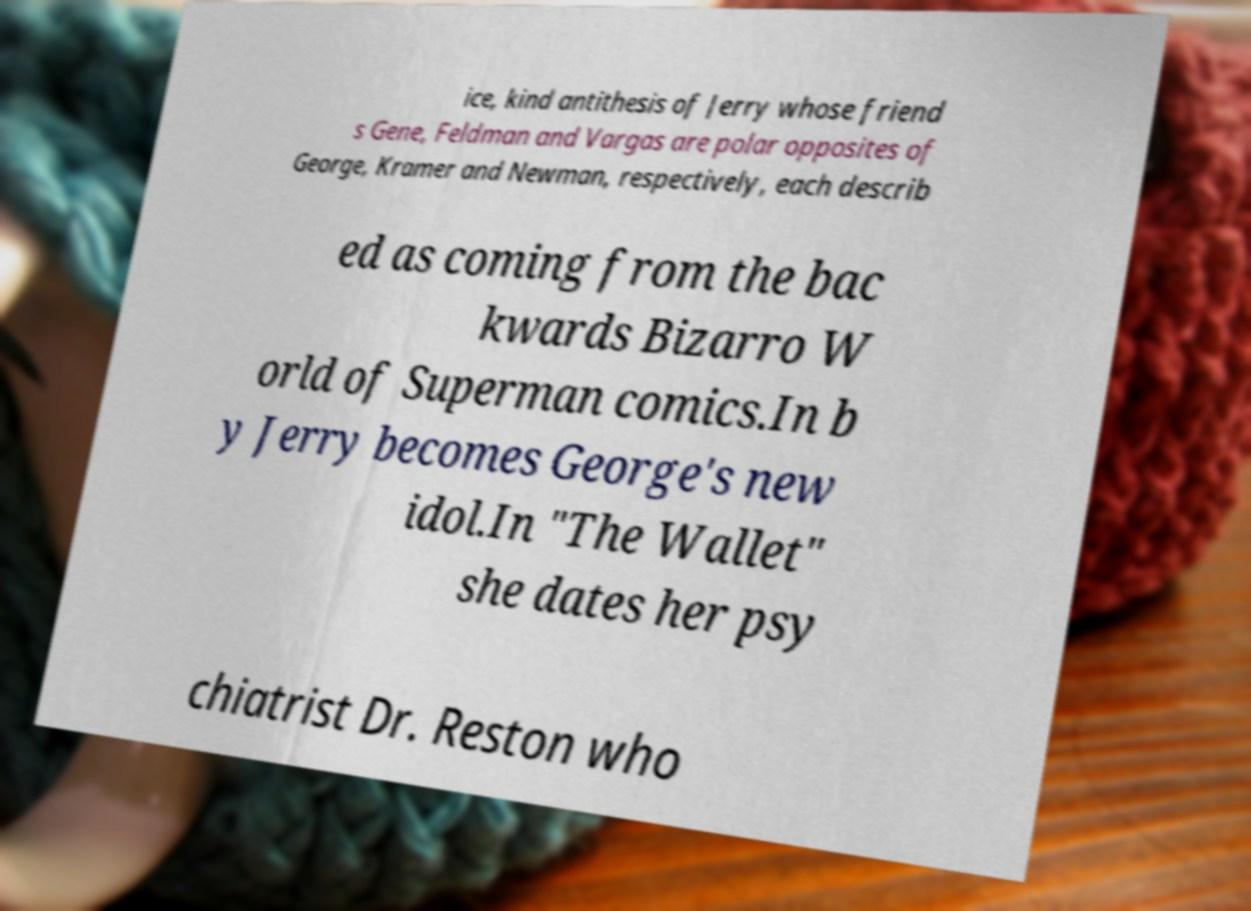Please identify and transcribe the text found in this image. ice, kind antithesis of Jerry whose friend s Gene, Feldman and Vargas are polar opposites of George, Kramer and Newman, respectively, each describ ed as coming from the bac kwards Bizarro W orld of Superman comics.In b y Jerry becomes George's new idol.In "The Wallet" she dates her psy chiatrist Dr. Reston who 